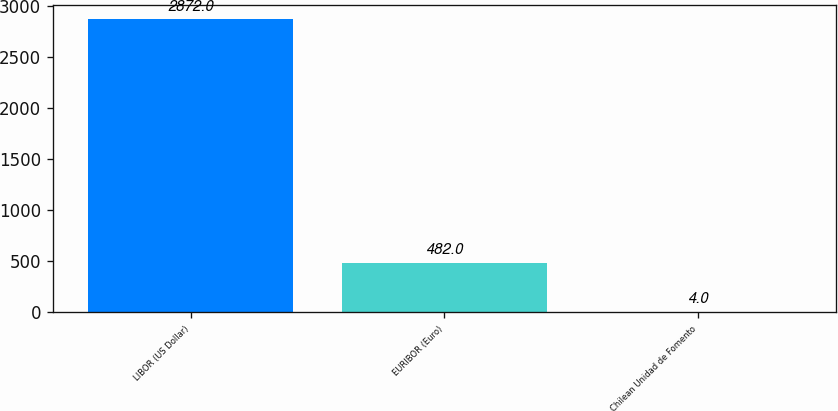<chart> <loc_0><loc_0><loc_500><loc_500><bar_chart><fcel>LIBOR (US Dollar)<fcel>EURIBOR (Euro)<fcel>Chilean Unidad de Fomento<nl><fcel>2872<fcel>482<fcel>4<nl></chart> 